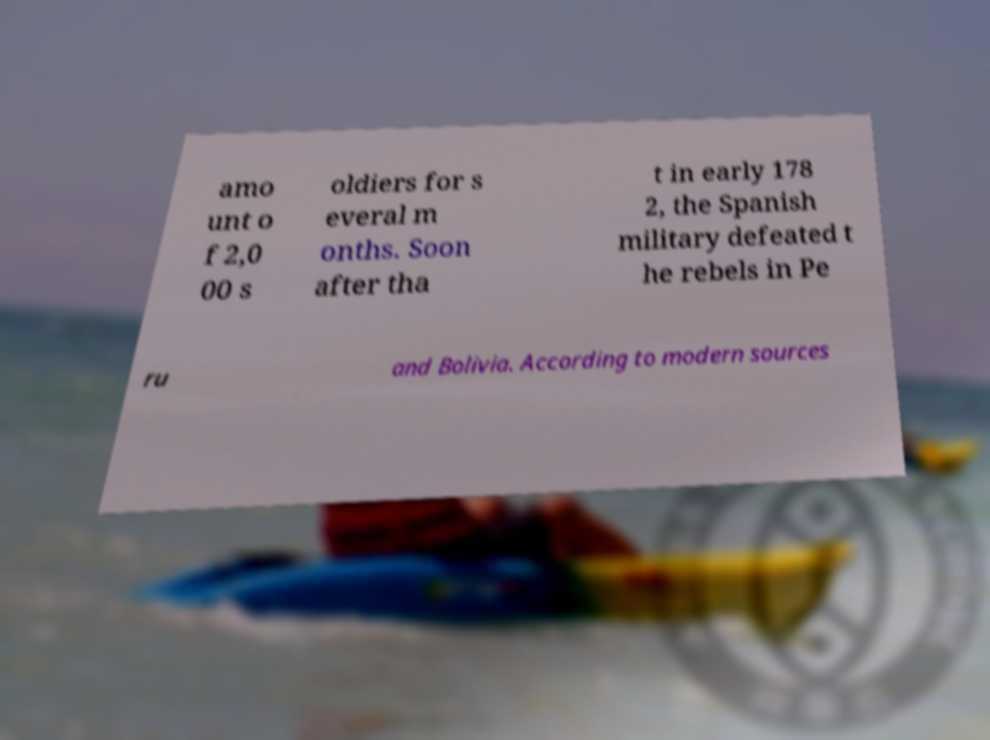I need the written content from this picture converted into text. Can you do that? amo unt o f 2,0 00 s oldiers for s everal m onths. Soon after tha t in early 178 2, the Spanish military defeated t he rebels in Pe ru and Bolivia. According to modern sources 